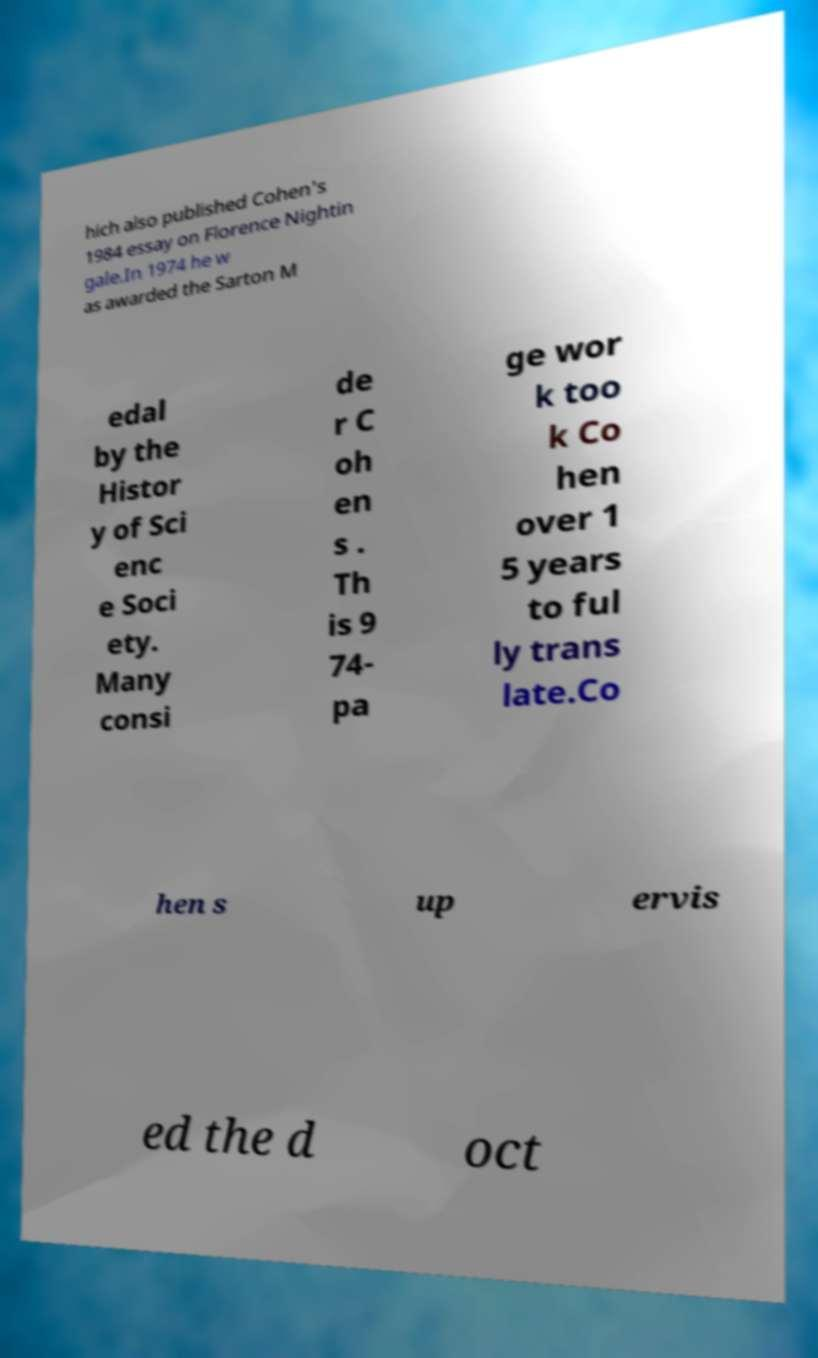There's text embedded in this image that I need extracted. Can you transcribe it verbatim? hich also published Cohen's 1984 essay on Florence Nightin gale.In 1974 he w as awarded the Sarton M edal by the Histor y of Sci enc e Soci ety. Many consi de r C oh en s . Th is 9 74- pa ge wor k too k Co hen over 1 5 years to ful ly trans late.Co hen s up ervis ed the d oct 